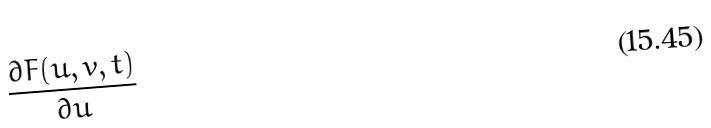<formula> <loc_0><loc_0><loc_500><loc_500>\frac { \partial F ( u , v , t ) } { \partial u }</formula> 